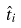<formula> <loc_0><loc_0><loc_500><loc_500>\hat { t } _ { i }</formula> 